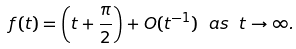Convert formula to latex. <formula><loc_0><loc_0><loc_500><loc_500>\ f ( t ) = \left ( t + \frac { \pi } { 2 } \right ) + O ( t ^ { - 1 } ) \ a s \ t \to \infty .</formula> 